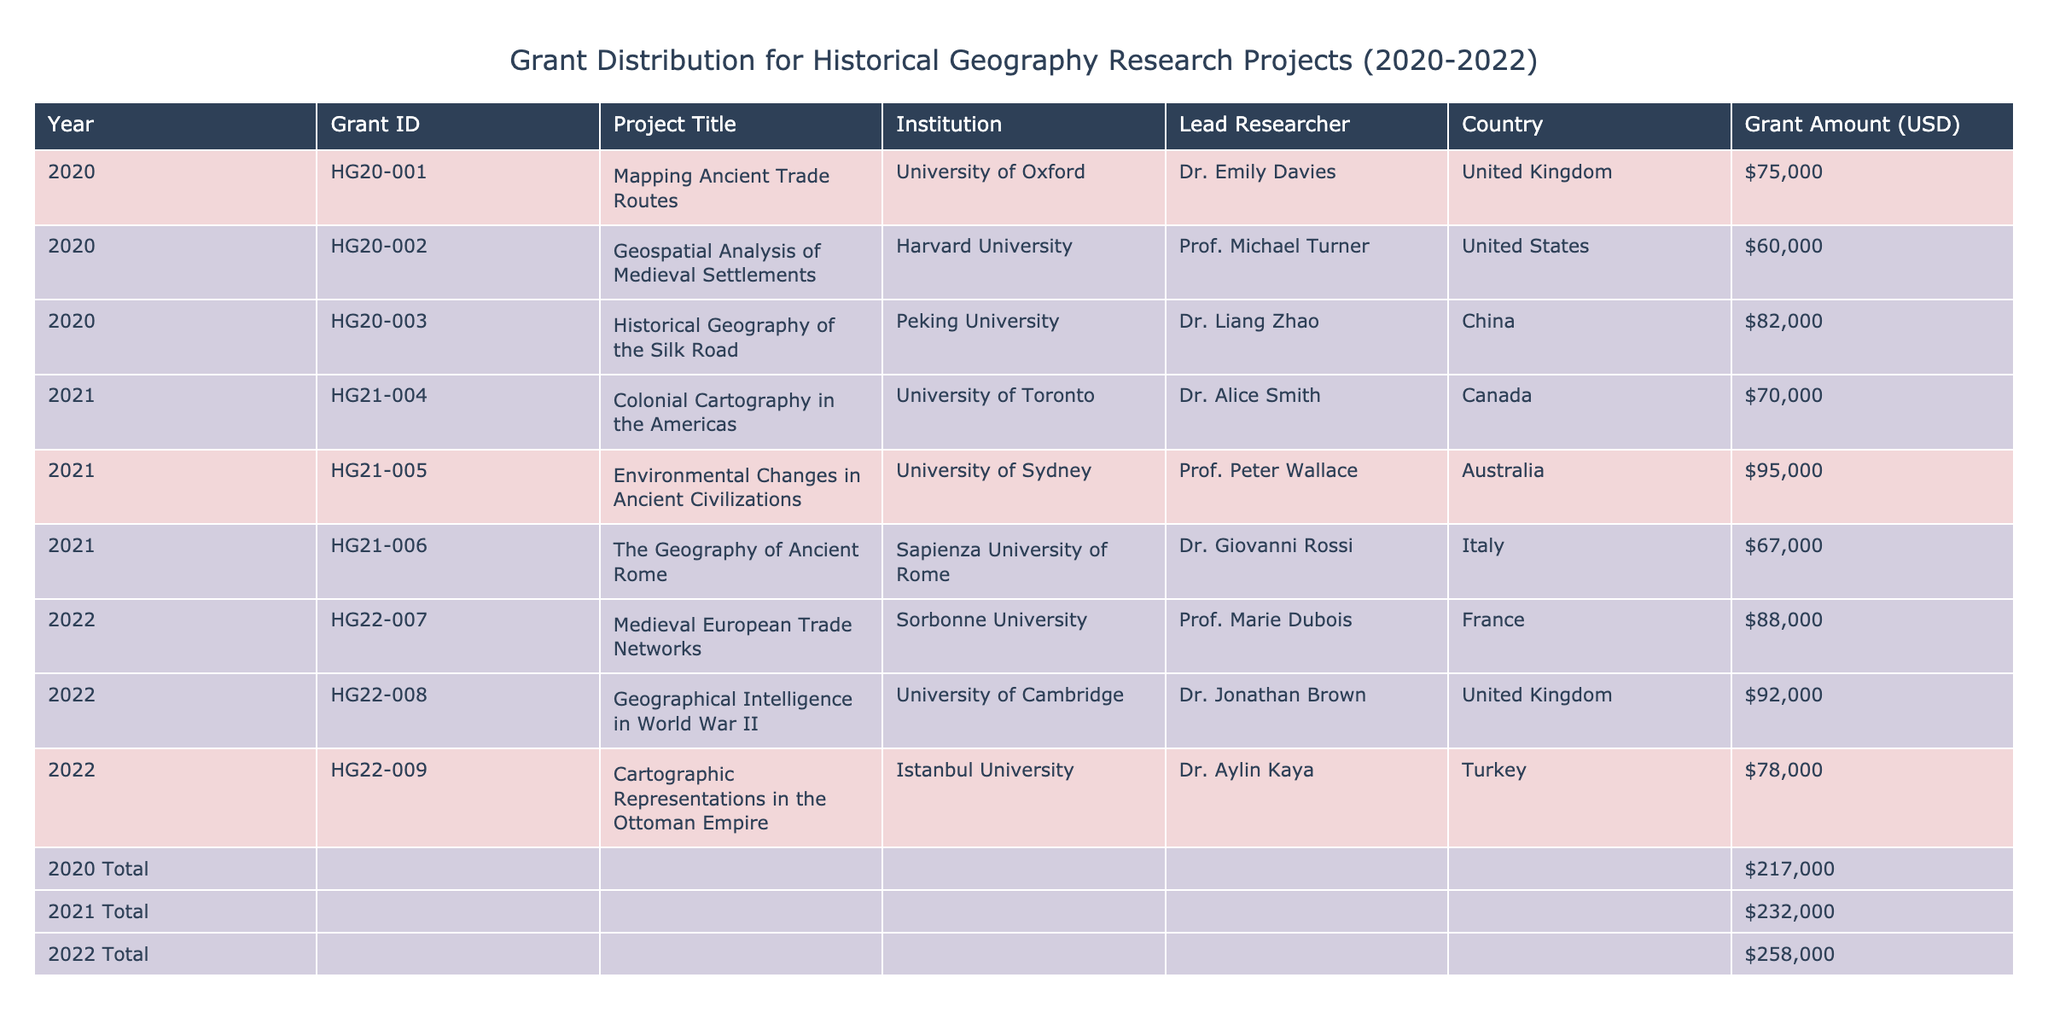What is the grant amount for the project titled "The Geography of Ancient Rome"? By searching through the table, I find the project "The Geography of Ancient Rome" listed under the year 2021 with a corresponding grant amount of 67,000 USD.
Answer: 67,000 USD Which institution received the highest grant amount in 2022? From the 2022 section of the table, I can see the grants awarded to three institutions: Sorbonne University (88,000 USD), University of Cambridge (92,000 USD), and Istanbul University (78,000 USD). The University of Cambridge received the highest amount of 92,000 USD.
Answer: University of Cambridge How much total funding was allocated for all projects in 2021? The table shows three projects in 2021 with the following grant amounts: 70,000 USD, 95,000 USD, and 67,000 USD. Adding these amounts gives: 70,000 + 95,000 + 67,000 = 232,000 USD.
Answer: 232,000 USD Did any project in 2020 receive a grant amount greater than 75,000 USD? Looking through the 2020 entries, there are three projects with amounts: 75,000 USD, 60,000 USD, and 82,000 USD. The project "Historical Geography of the Silk Road" received 82,000 USD, which is greater than 75,000 USD.
Answer: Yes What is the average grant amount for projects conducted by researchers from the United States? The projects from researchers in the United States include one project with a grant amount of 60,000 USD in 2020 (Geospatial Analysis of Medieval Settlements). Since there is only one project, the average is simply 60,000 USD.
Answer: 60,000 USD Which country had the least funding awarded in 2020, and what was the amount? The table shows three entries from 2020 with the following amounts: United Kingdom (75,000 USD), United States (60,000 USD), and China (82,000 USD). The least amount awarded is to the United States with 60,000 USD.
Answer: United States, 60,000 USD In which year was the total grant amount the highest? Evaluating the total grant amounts for each year: 2020 (75,000 + 60,000 + 82,000 = 217,000 USD), 2021 (70,000 + 95,000 + 67,000 = 232,000 USD), and 2022 (88,000 + 92,000 + 78,000 = 258,000 USD). The highest total is in 2022 with 258,000 USD.
Answer: 2022 How many projects were funded by Canadian institutions during the entire period? From the table, it shows that in 2021 there was one project from a Canadian institution (University of Toronto) funded for 70,000 USD. Thus, the total number of projects from Canada is one.
Answer: 1 